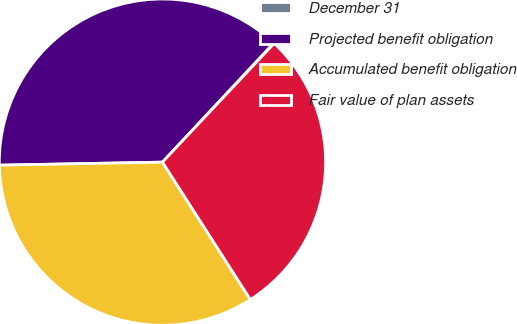Convert chart to OTSL. <chart><loc_0><loc_0><loc_500><loc_500><pie_chart><fcel>December 31<fcel>Projected benefit obligation<fcel>Accumulated benefit obligation<fcel>Fair value of plan assets<nl><fcel>0.06%<fcel>37.25%<fcel>33.76%<fcel>28.93%<nl></chart> 